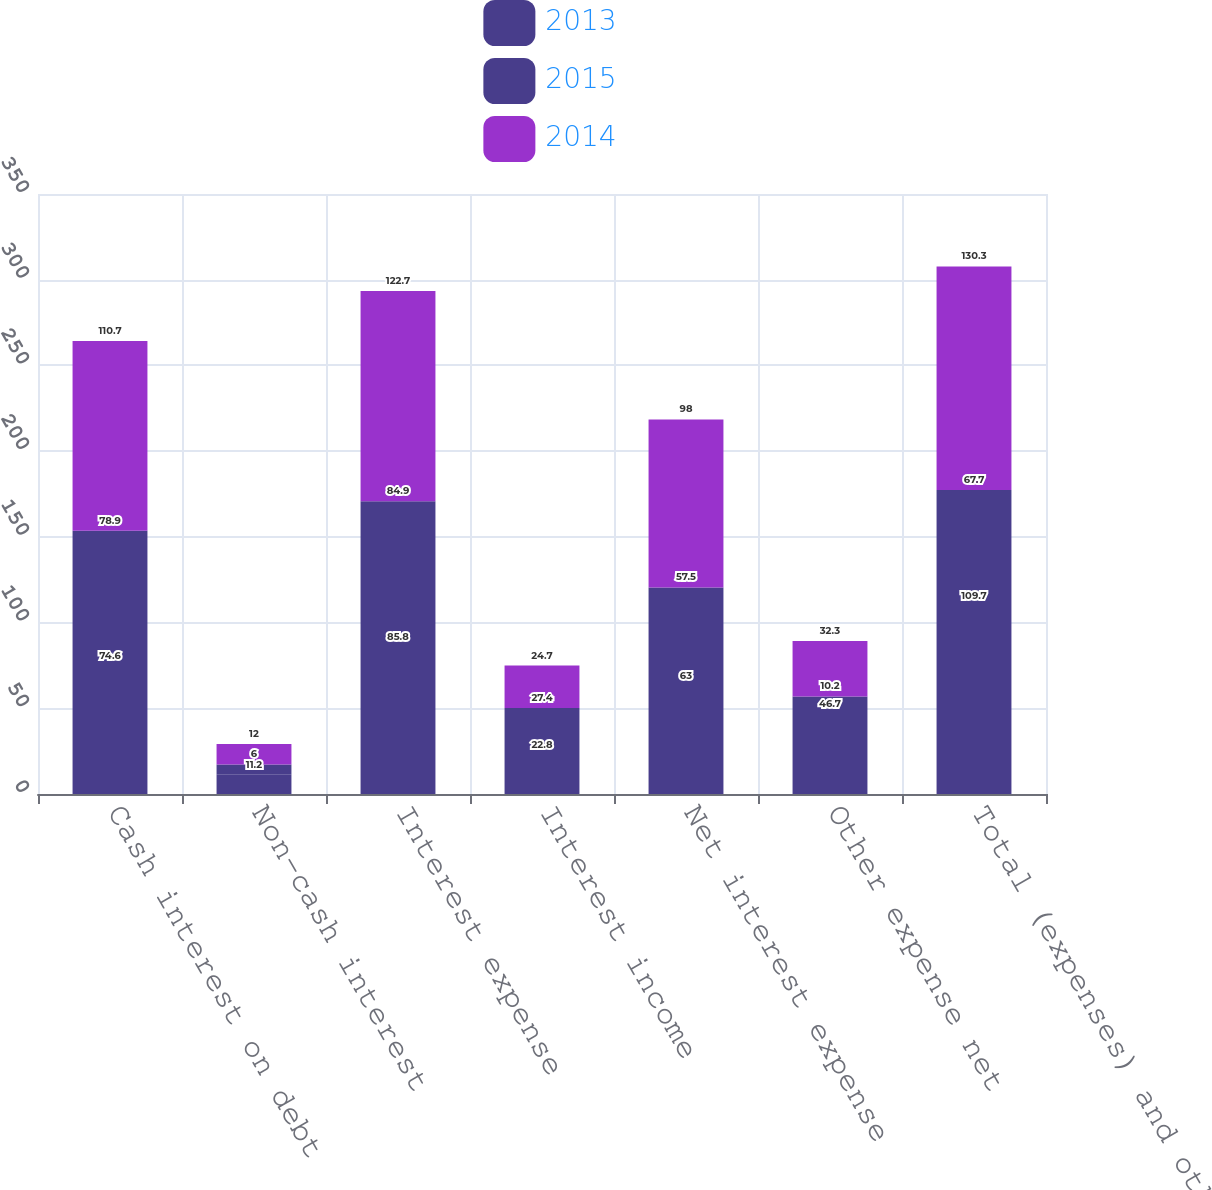<chart> <loc_0><loc_0><loc_500><loc_500><stacked_bar_chart><ecel><fcel>Cash interest on debt<fcel>Non-cash interest<fcel>Interest expense<fcel>Interest income<fcel>Net interest expense<fcel>Other expense net<fcel>Total (expenses) and other<nl><fcel>2013<fcel>74.6<fcel>11.2<fcel>85.8<fcel>22.8<fcel>63<fcel>46.7<fcel>109.7<nl><fcel>2015<fcel>78.9<fcel>6<fcel>84.9<fcel>27.4<fcel>57.5<fcel>10.2<fcel>67.7<nl><fcel>2014<fcel>110.7<fcel>12<fcel>122.7<fcel>24.7<fcel>98<fcel>32.3<fcel>130.3<nl></chart> 